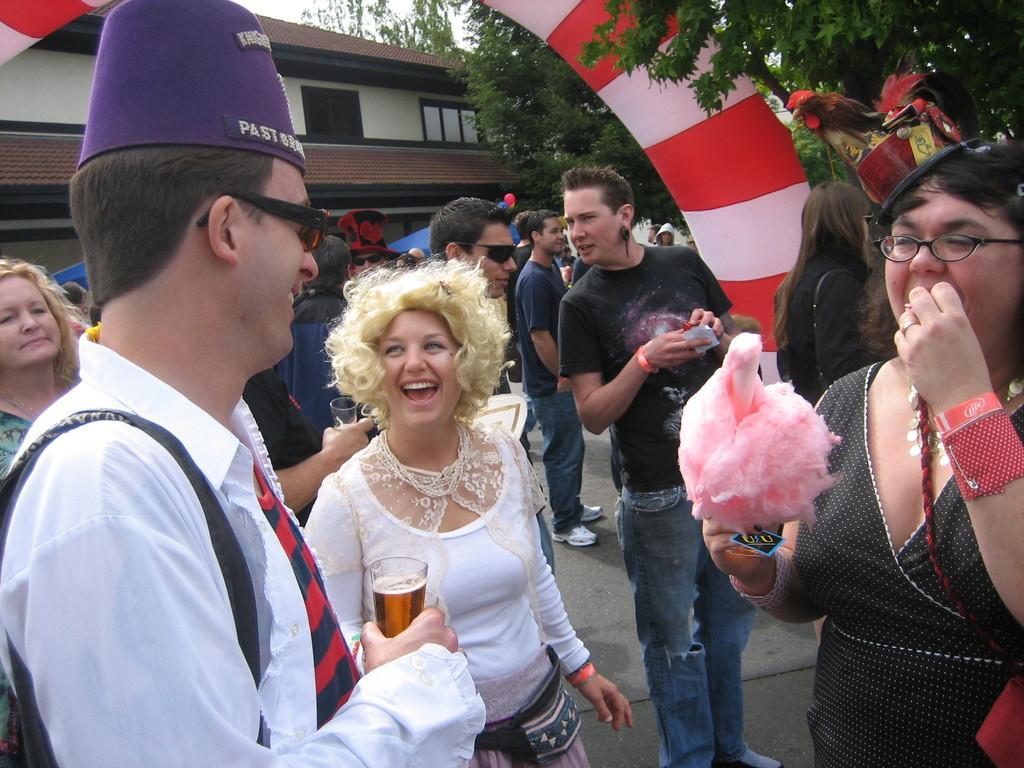Can you describe this image briefly? In this picture there is a group of girls and boys standing in the party, smiling and enjoying. On the right side there is a woman wearing black top eating a pink sugar candy. Behind there is a red and white color arch balloon. In the background there are some trees and small house. 